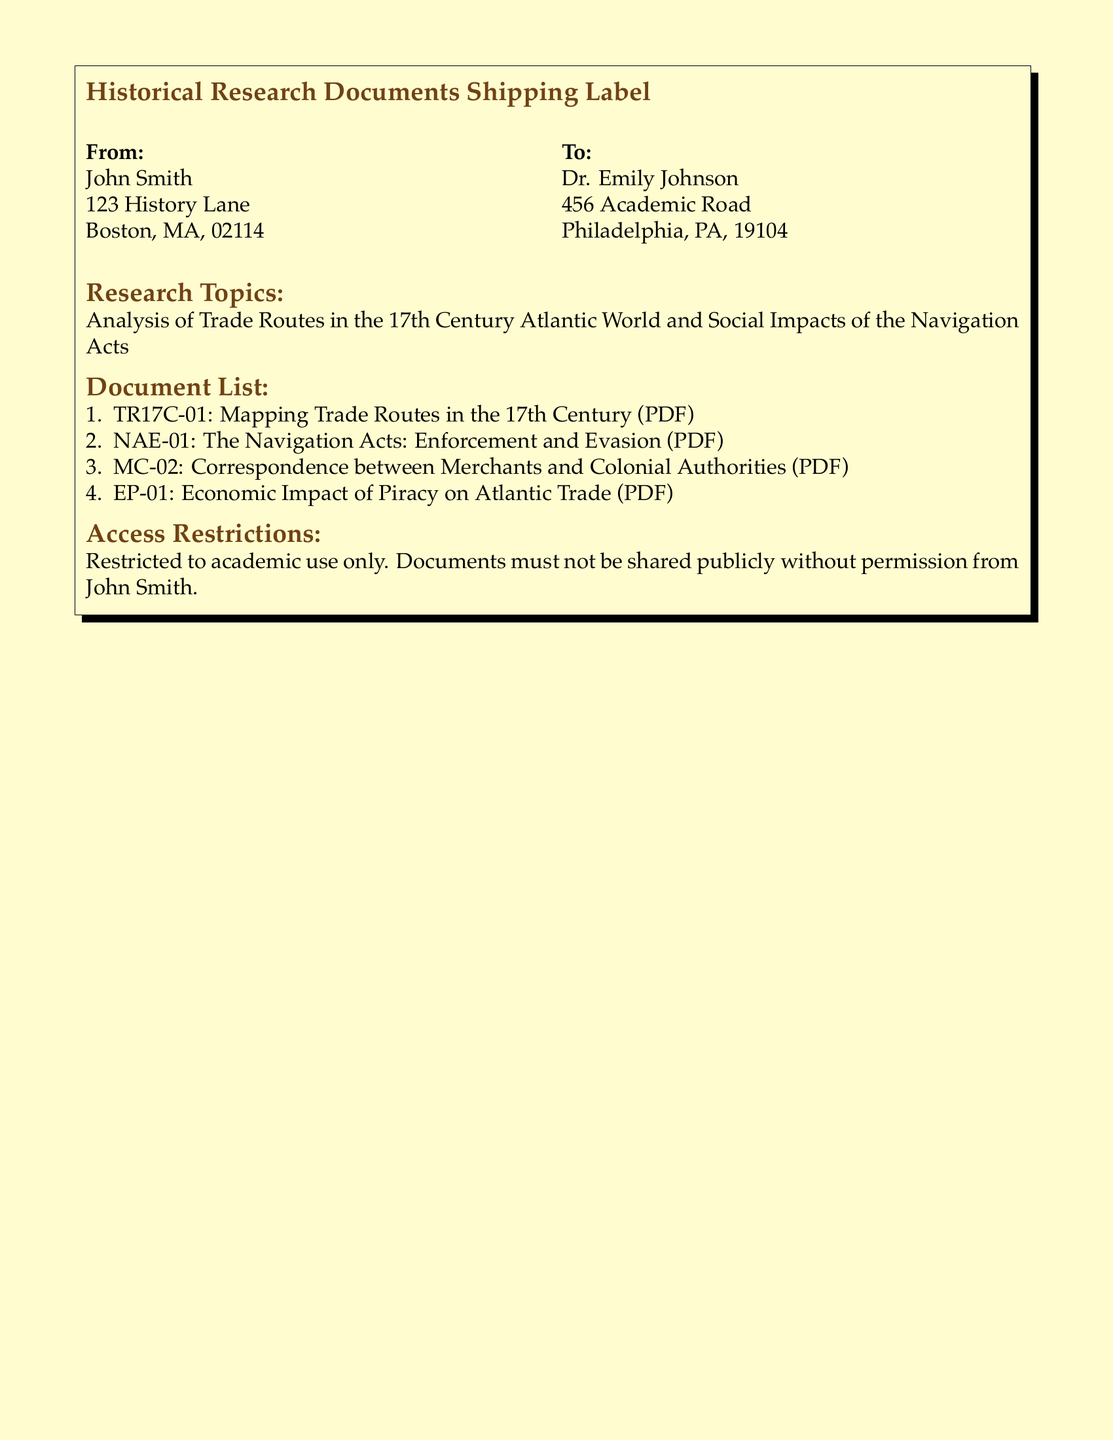What is the sender's name? The sender's name is provided in the "From" section of the document.
Answer: John Smith What is the recipient's address? The recipient's address can be found in the "To" section of the document.
Answer: 456 Academic Road, Philadelphia, PA, 19104 How many documents are listed? The total number of documents is mentioned in the "Document List" section.
Answer: 4 What is the title of the first document? The title of the first document is in the list under "Document List."
Answer: Mapping Trade Routes in the 17th Century What is the primary research topic mentioned? The main research topic is described in the "Research Topics" section of the document.
Answer: Analysis of Trade Routes in the 17th Century Atlantic World What is the restriction on document sharing? The access restrictions state how documents can be used or shared.
Answer: Restricted to academic use only Which period do the research topics focus on? The research topics indicate the historical period being studied.
Answer: 17th Century What format are the documents in? The document mentions the format in the list of documents.
Answer: PDF 